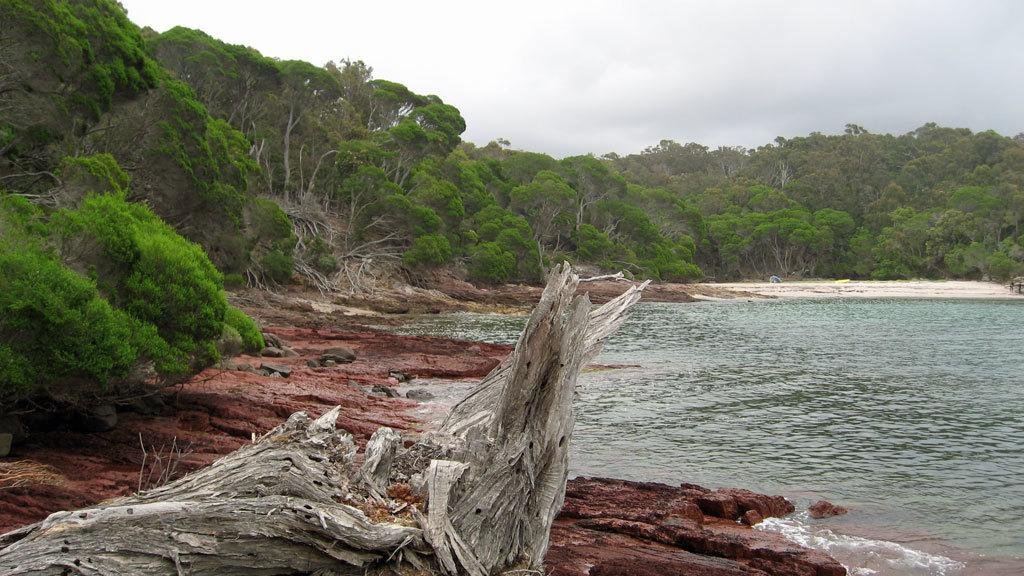What can be seen in the right corner of the image? There is water in the right corner of the image. What type of natural environment is visible in the background of the image? There are trees in the background of the image. Can you see a ghost in the image? No, there is no ghost present in the image. What type of addition problem can be solved using the water in the image? There is no addition problem present in the image, as it only features water in the right corner. 